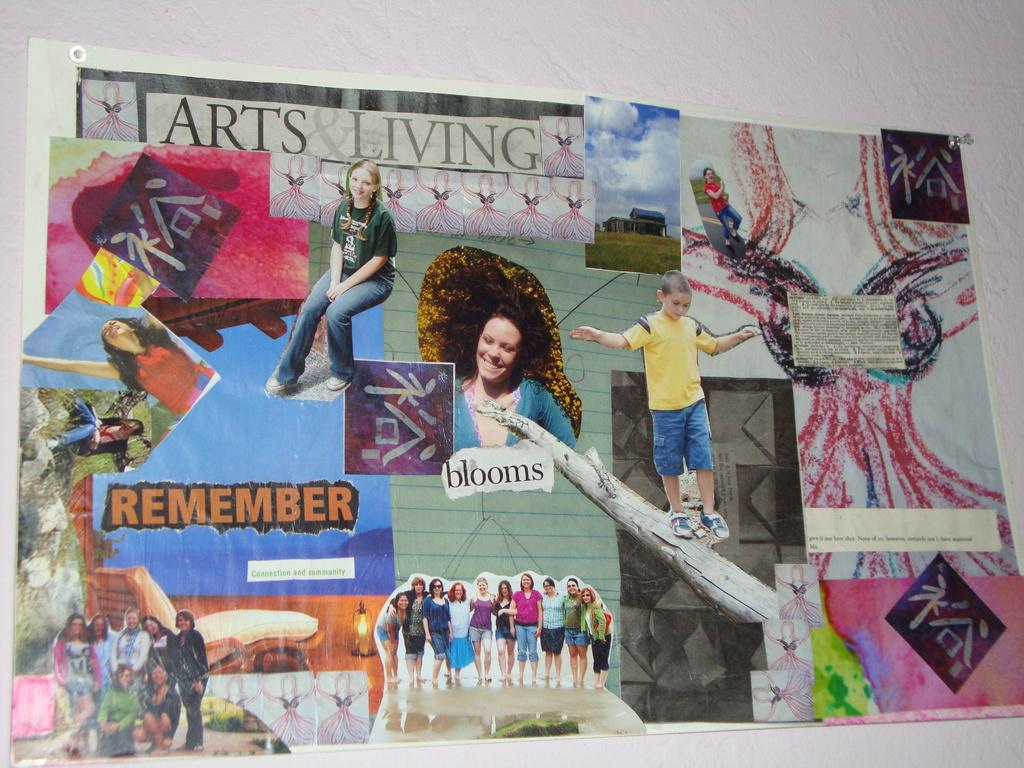<image>
Offer a succinct explanation of the picture presented. A bulletin board includes a collage titled Arts & Living. 